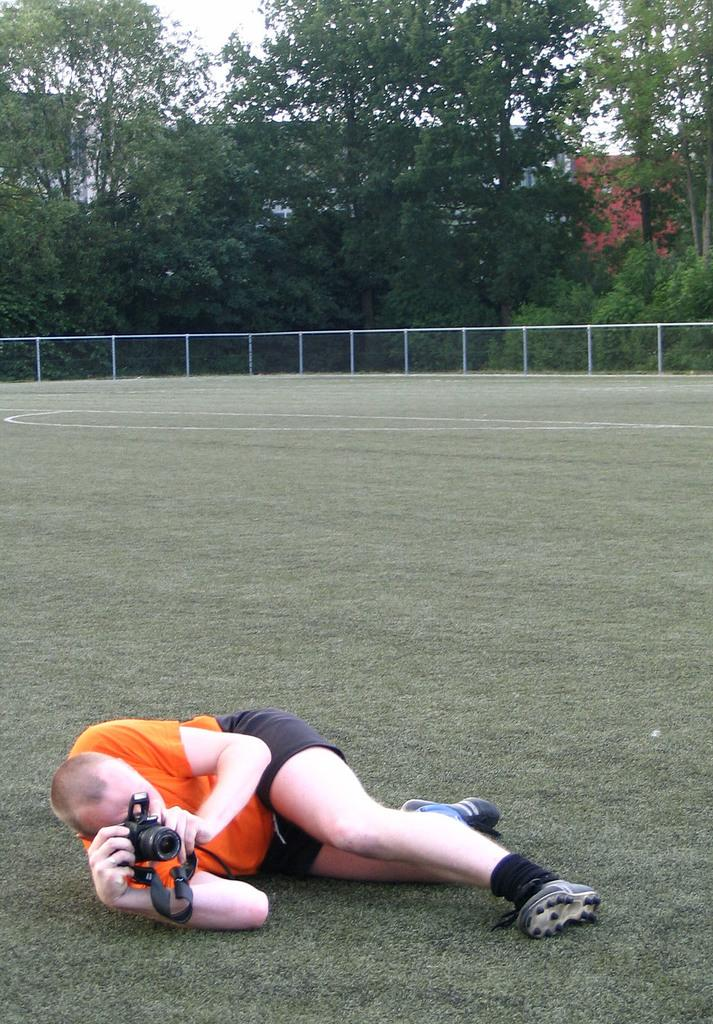What is the surface of the ground covered with in the image? The ground is covered in grass. What is the person in the image doing? The person is lying on the ground. What is the person holding in the image? The person is holding a camera. What can be seen in the background of the image? There are railings and trees in the background. Where are the kittens sleeping in the image? There are no kittens present in the image. 